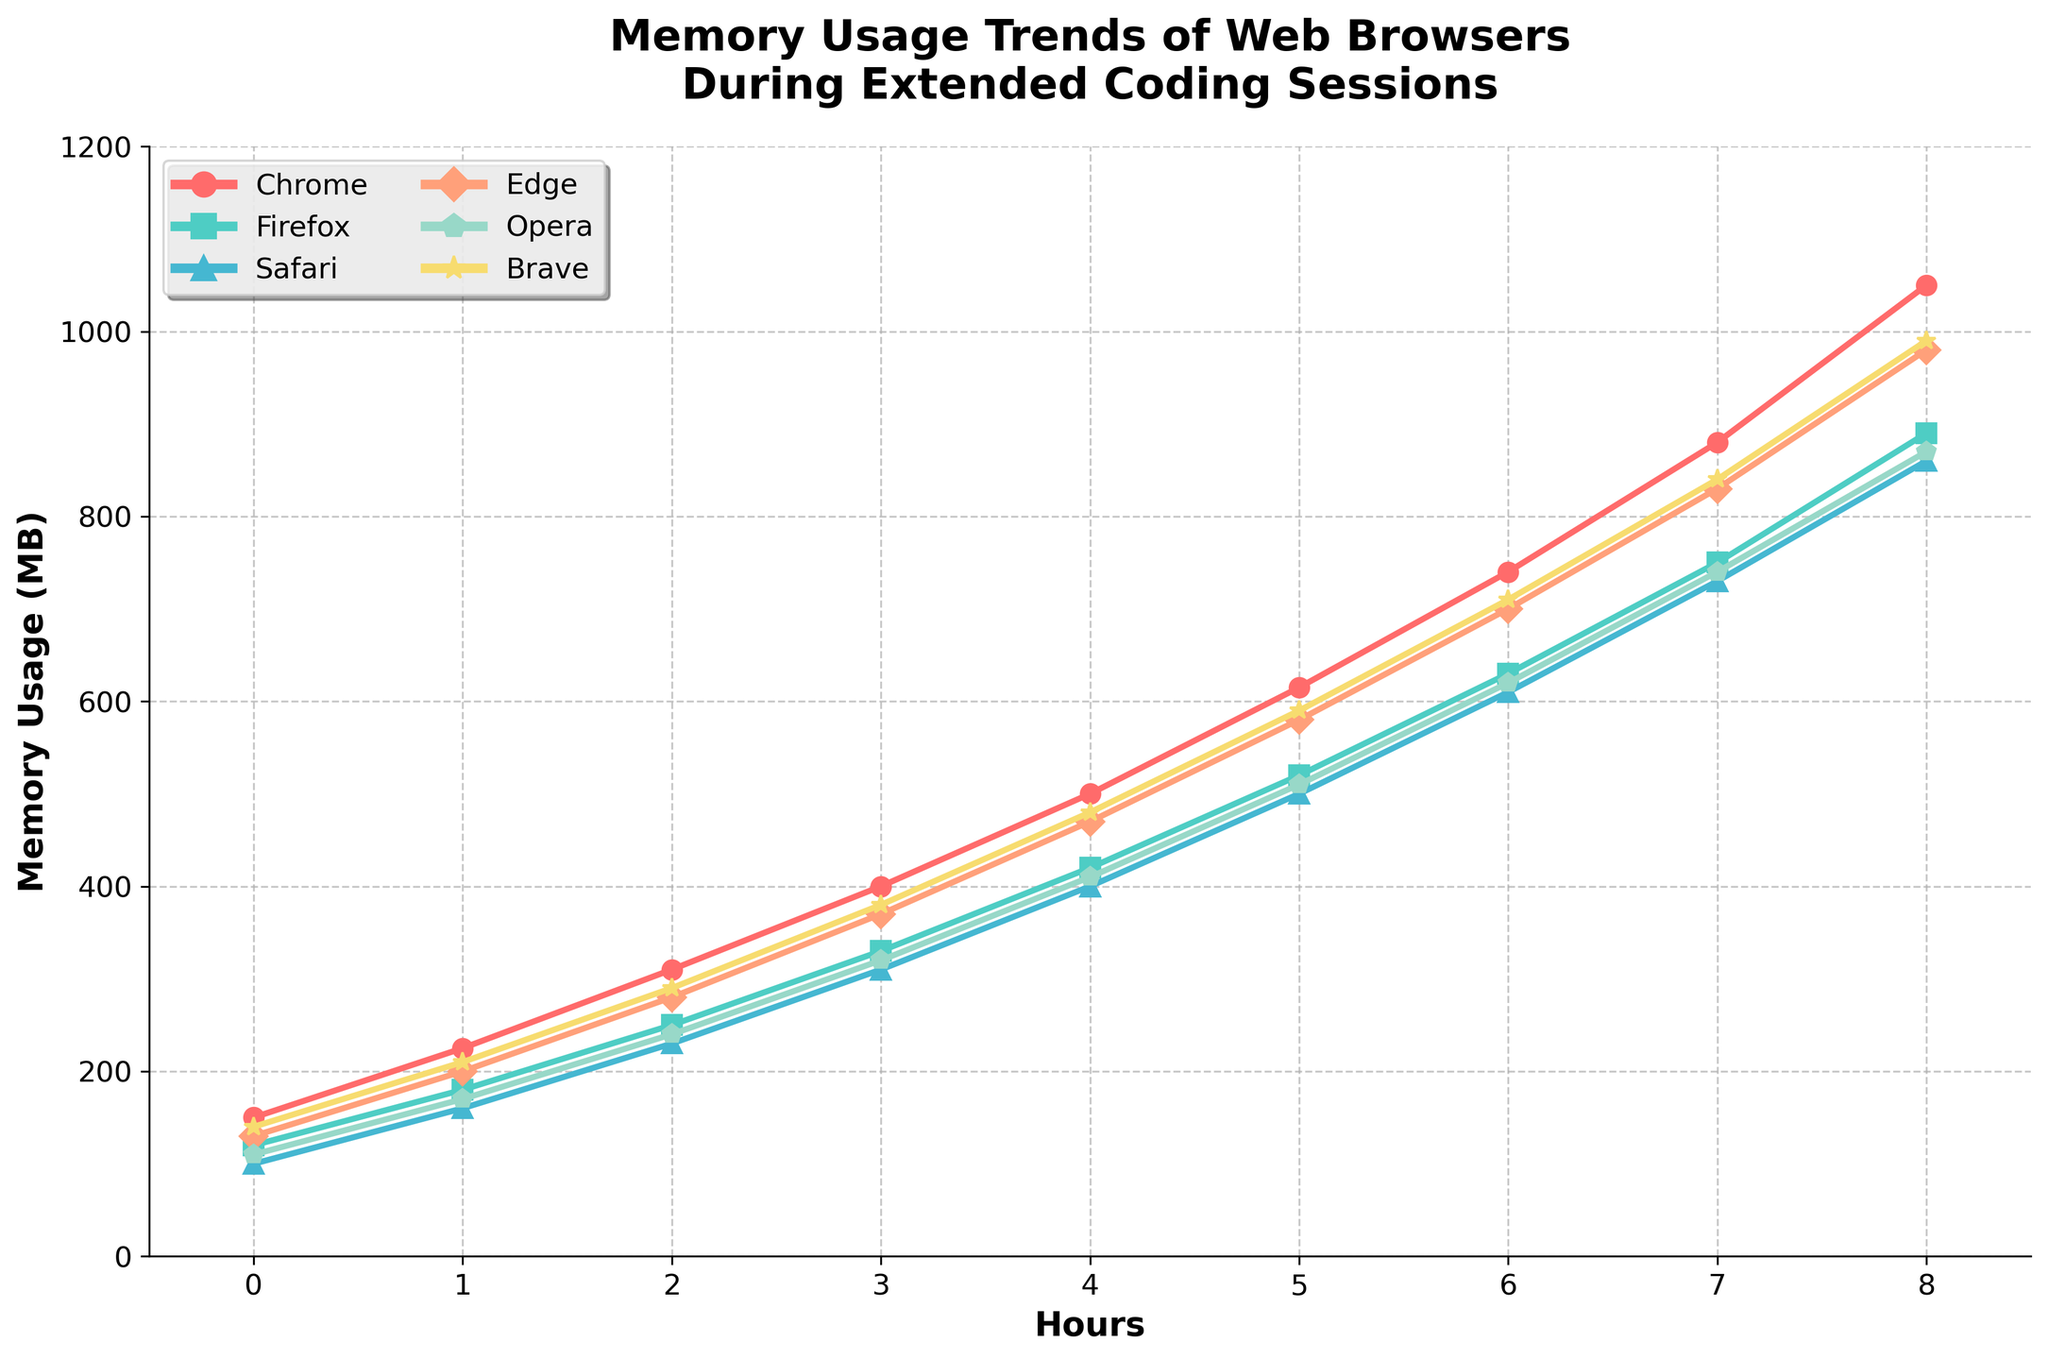What browser uses the least memory after 4 hours? Safari uses 400MB, which is the lowest among all the browsers.
Answer: Safari How much more memory does Chrome use than Firefox after 8 hours? Chrome uses 1050MB and Firefox uses 890MB after 8 hours. The difference is 1050MB - 890MB = 160MB.
Answer: 160MB Which web browser's memory usage increases the fastest between 0 and 8 hours? Chrome shows the most significant increase from 150MB to 1050MB. This is an increase of 900MB, which is the highest compared to other browsers.
Answer: Chrome What is the average memory usage of Brave throughout the 8-hour session? The memory usages are 140, 210, 290, 380, 480, 590, 710, 840, and 990MB. The average is calculated as (140 + 210 + 290 + 380 + 480 + 590 + 710 + 840 + 990) / 9 = 513.33MB.
Answer: 513.33MB Compare the memory usage of Opera and Edge after 5 hours. Which browser uses more memory? Opera uses 510MB and Edge uses 580MB. Edge uses more memory.
Answer: Edge Which browser shows the least variation in memory usage over the 8 hours? The differences between the highest and lowest memory usage values for each browser indicate Safari with (860-100) = 760MB. Safari has the smallest range.
Answer: Safari At what hour does Chrome's memory usage surpass 500MB? Chrome's memory usage surpasses 500MB between the 4th and 5th hour, precisely at the 5th hour.
Answer: 5 hours How much memory does Firefox use on average between 3 and 6 hours? The memory usage between 3 and 6 hours is 330, 420, 520, 630MB. The average is (330 + 420 + 520 + 630) / 4 = 475MB.
Answer: 475MB What color is used to represent Firefox in the chart? By observing the colored lines, Firefox is represented by green.
Answer: green 